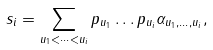<formula> <loc_0><loc_0><loc_500><loc_500>s _ { i } = \sum _ { u _ { 1 } < \dots < u _ { i } } p _ { u _ { 1 } } \dots p _ { u _ { i } } \alpha _ { u _ { 1 } , \dots , u _ { i } } ,</formula> 